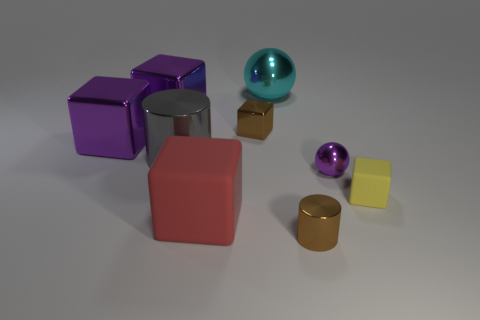Is there any other thing that has the same material as the red thing?
Your answer should be very brief. Yes. What is the size of the object that is the same color as the small cylinder?
Ensure brevity in your answer.  Small. Is the small cylinder the same color as the small metal block?
Give a very brief answer. Yes. What number of other objects are there of the same color as the big rubber object?
Your answer should be very brief. 0. What number of blue rubber things are there?
Ensure brevity in your answer.  0. Is the number of rubber objects right of the brown block less than the number of big gray metal cubes?
Offer a very short reply. No. Are the cylinder that is left of the cyan metallic sphere and the tiny yellow thing made of the same material?
Ensure brevity in your answer.  No. What shape is the tiny thing in front of the matte object that is in front of the cube to the right of the cyan ball?
Provide a succinct answer. Cylinder. Is there a metal thing of the same size as the cyan sphere?
Provide a succinct answer. Yes. The cyan shiny ball has what size?
Your answer should be very brief. Large. 